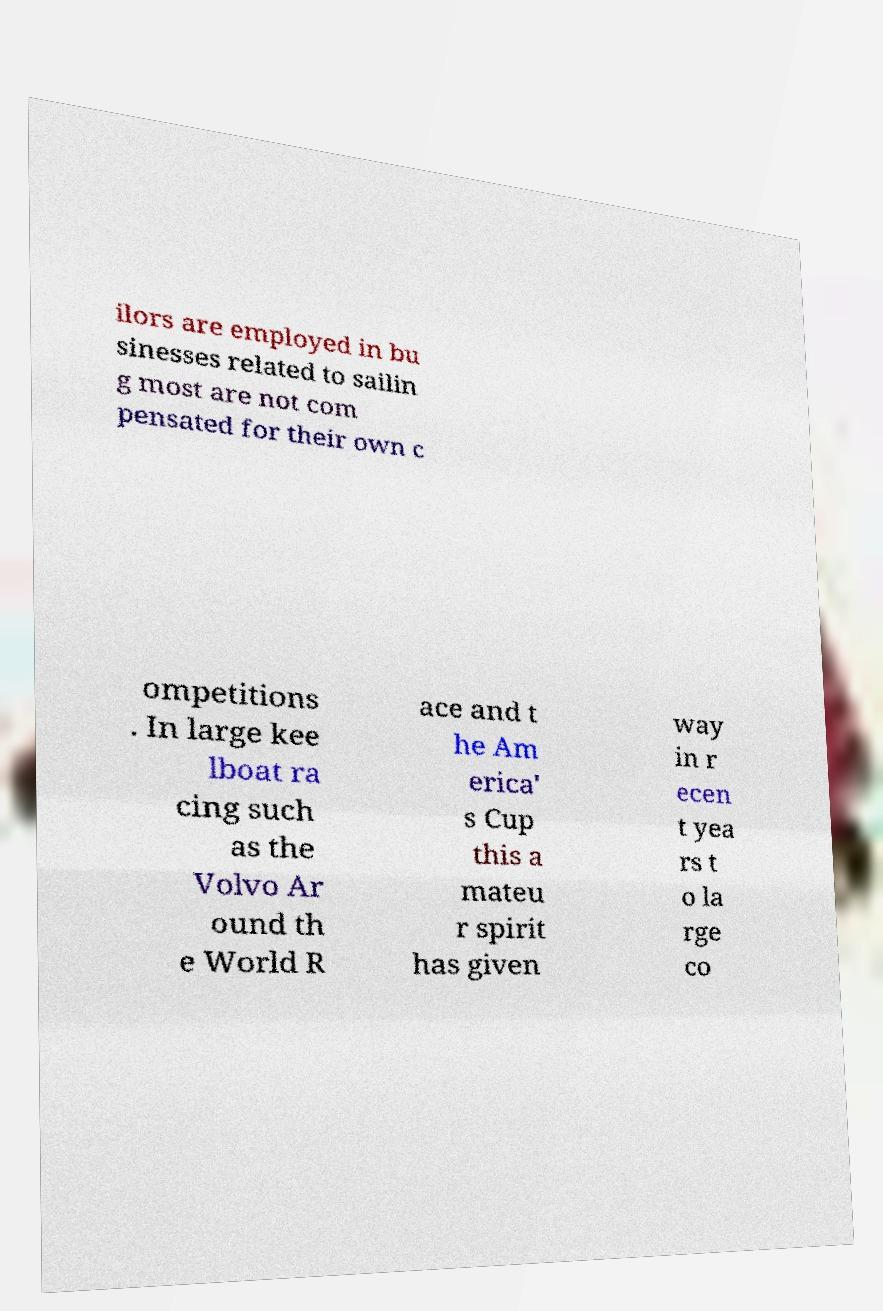Please identify and transcribe the text found in this image. ilors are employed in bu sinesses related to sailin g most are not com pensated for their own c ompetitions . In large kee lboat ra cing such as the Volvo Ar ound th e World R ace and t he Am erica' s Cup this a mateu r spirit has given way in r ecen t yea rs t o la rge co 